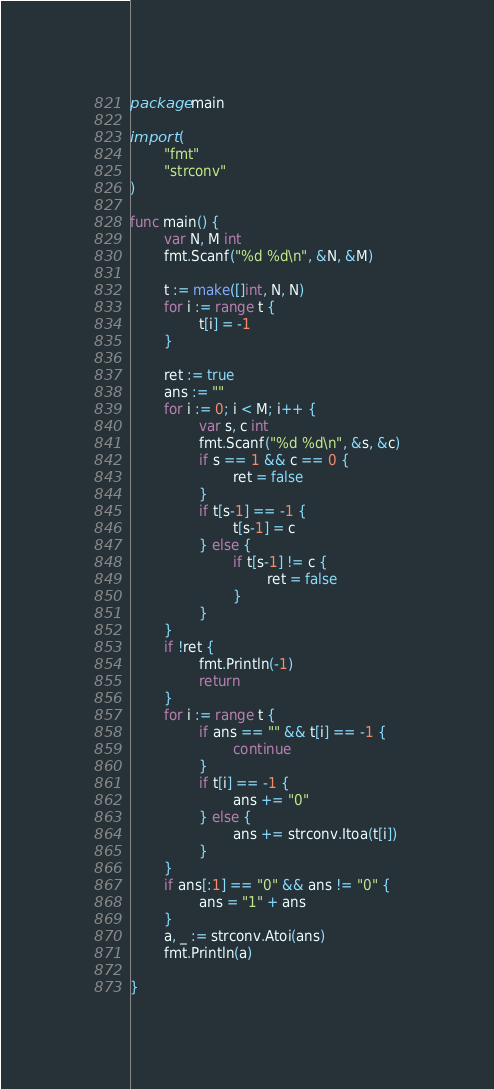<code> <loc_0><loc_0><loc_500><loc_500><_Go_>package main

import (
        "fmt"
        "strconv"
)

func main() {
        var N, M int
        fmt.Scanf("%d %d\n", &N, &M)

        t := make([]int, N, N)
        for i := range t {
                t[i] = -1
        }

        ret := true
        ans := ""
        for i := 0; i < M; i++ {
                var s, c int
                fmt.Scanf("%d %d\n", &s, &c)
                if s == 1 && c == 0 {
                        ret = false
                }
                if t[s-1] == -1 {
                        t[s-1] = c
                } else {
                        if t[s-1] != c {
                                ret = false
                        }
                }
        }
        if !ret {
                fmt.Println(-1)
                return
        }
        for i := range t {
                if ans == "" && t[i] == -1 {
                        continue
                }
                if t[i] == -1 {
                        ans += "0"
                } else {
                        ans += strconv.Itoa(t[i])
                }
        }
        if ans[:1] == "0" && ans != "0" {
                ans = "1" + ans
        }
        a, _ := strconv.Atoi(ans)
        fmt.Println(a)

}</code> 